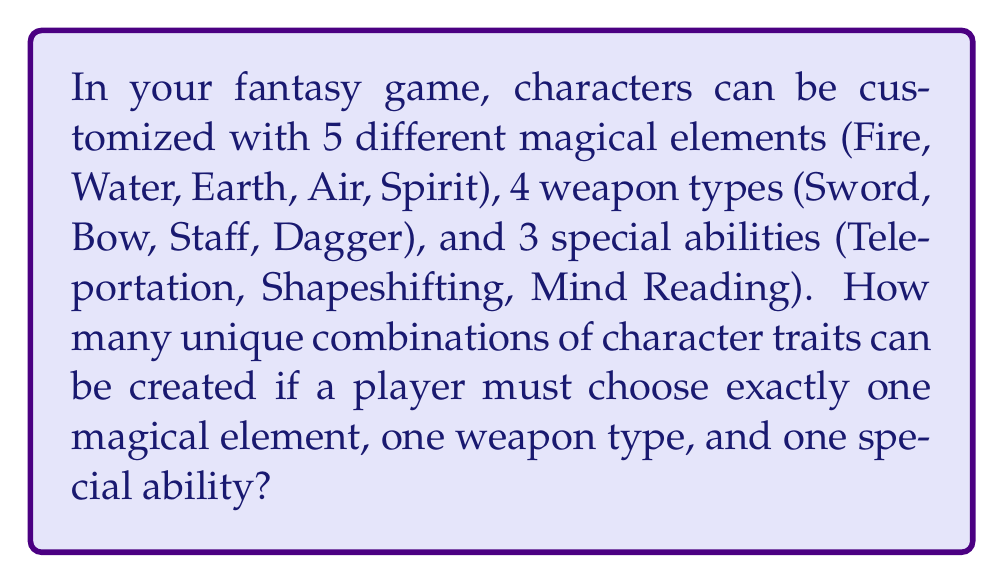Help me with this question. To solve this problem, we'll use the Multiplication Principle of Counting. This principle states that if we have $m$ ways of doing something, $n$ ways of doing another thing, and $p$ ways of doing a third thing, then there are $m \times n \times p$ ways of doing all three things.

Let's break down the choices:
1. Magical elements: 5 choices
2. Weapon types: 4 choices
3. Special abilities: 3 choices

Now, we multiply these numbers together:

$$5 \times 4 \times 3 = 60$$

This calculation gives us the total number of unique combinations possible when selecting one option from each category.

To understand why this works, consider that for each of the 5 magical elements, we have 4 weapon choices, giving us $5 \times 4 = 20$ element-weapon combinations. Then, for each of these 20 combinations, we have 3 special ability choices, resulting in $20 \times 3 = 60$ total unique combinations.

This method of counting ensures that we account for every possible combination of traits, allowing for maximum customization and variety in character creation, which aligns with the game creator's emphasis on imagination.
Answer: 60 